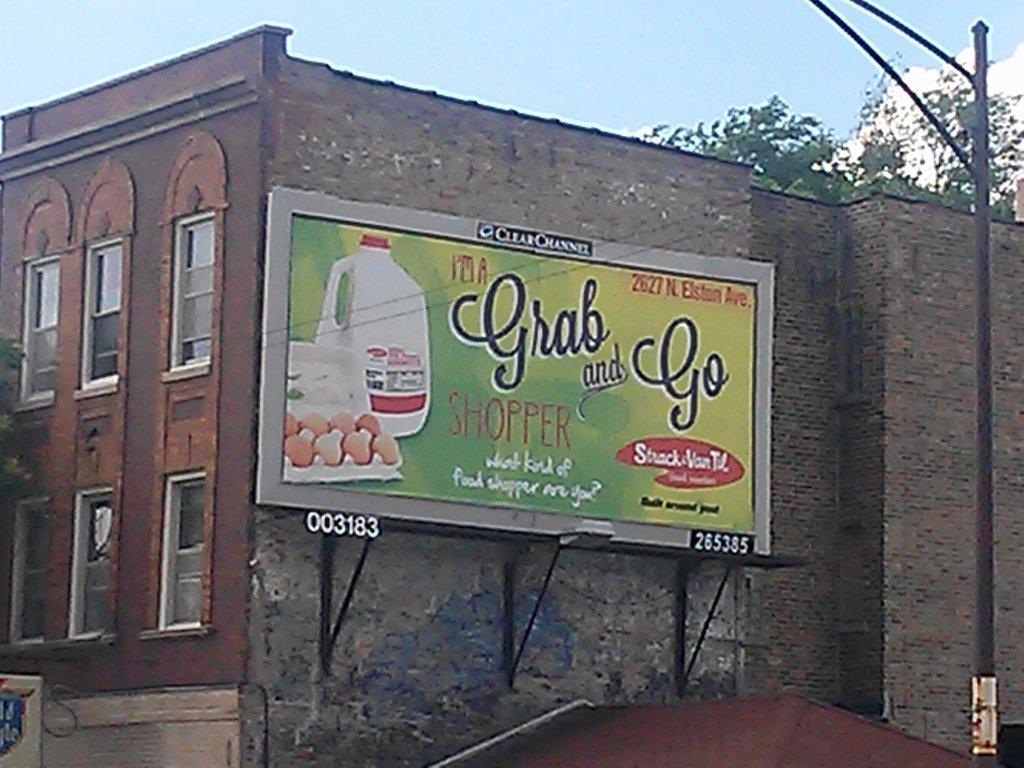<image>
Describe the image concisely. a billboard that says 'it's a grab and go shopper' 